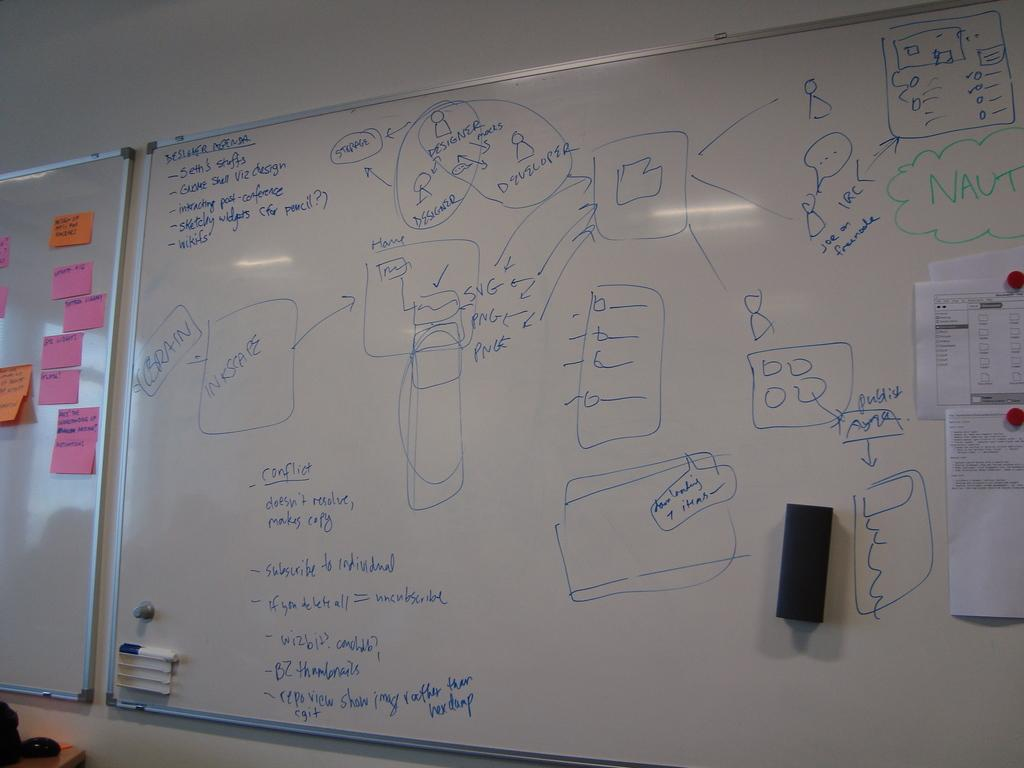<image>
Provide a brief description of the given image. A large white dry-erase board with phrases written on it including interacting post-conference 